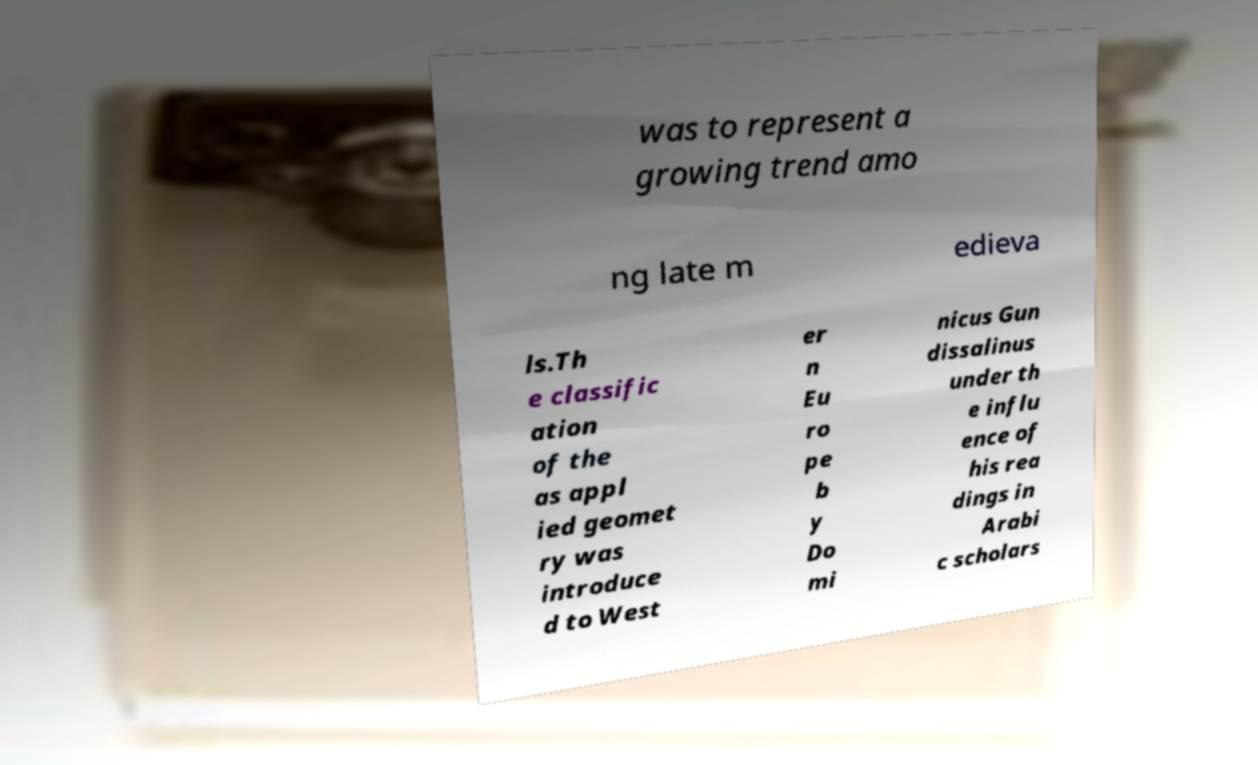For documentation purposes, I need the text within this image transcribed. Could you provide that? was to represent a growing trend amo ng late m edieva ls.Th e classific ation of the as appl ied geomet ry was introduce d to West er n Eu ro pe b y Do mi nicus Gun dissalinus under th e influ ence of his rea dings in Arabi c scholars 